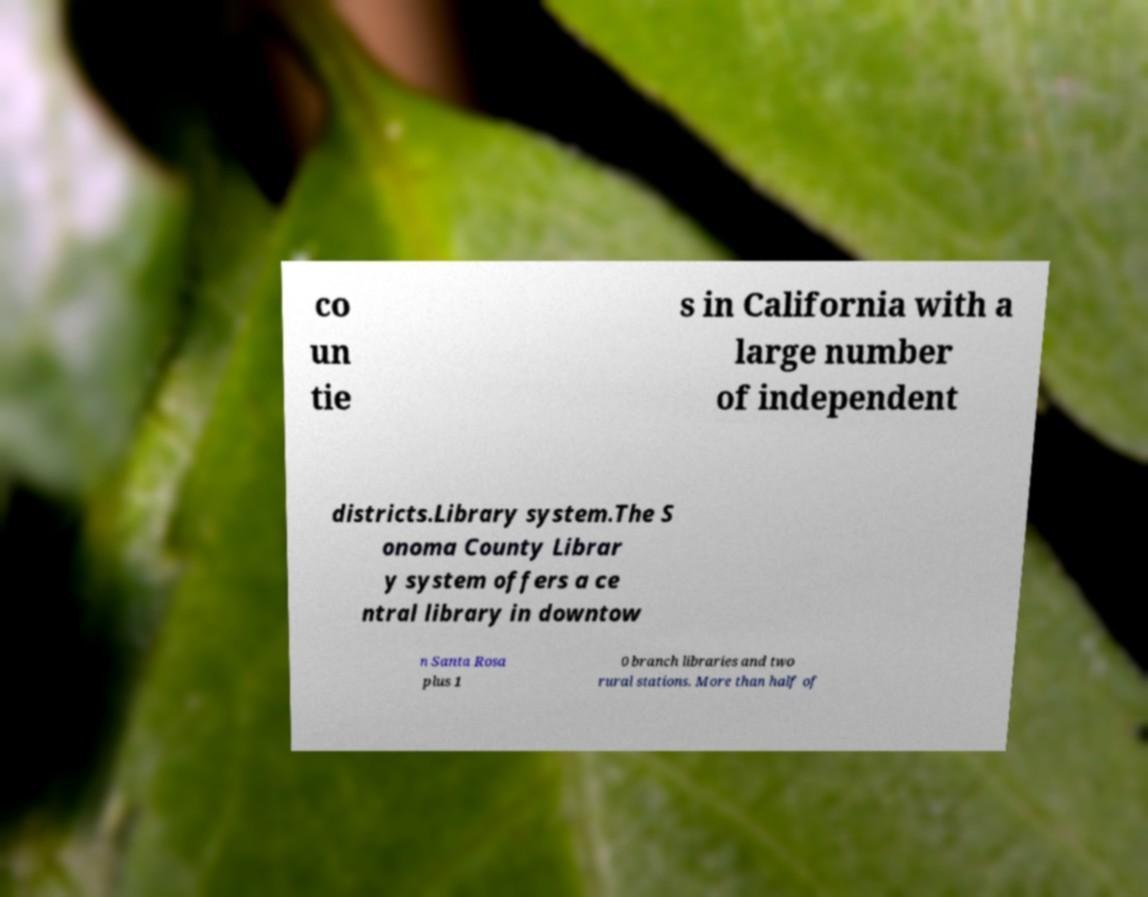Could you assist in decoding the text presented in this image and type it out clearly? co un tie s in California with a large number of independent districts.Library system.The S onoma County Librar y system offers a ce ntral library in downtow n Santa Rosa plus 1 0 branch libraries and two rural stations. More than half of 